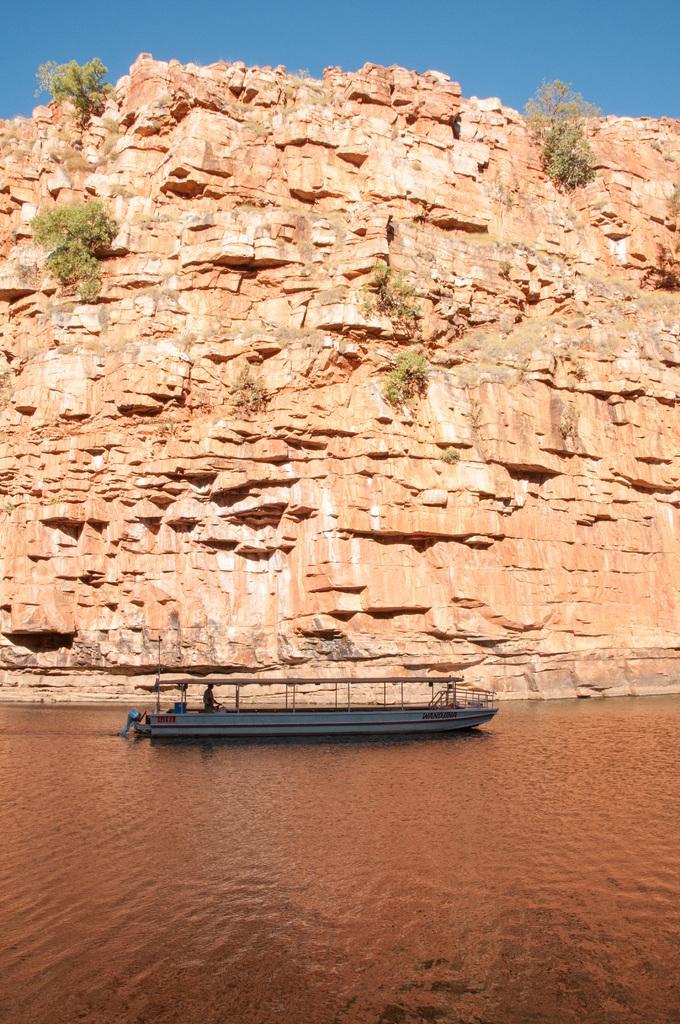How would you summarize this image in a sentence or two? In this image we can see a boat on the water, there are few plants on the rock and the sky in the background. 